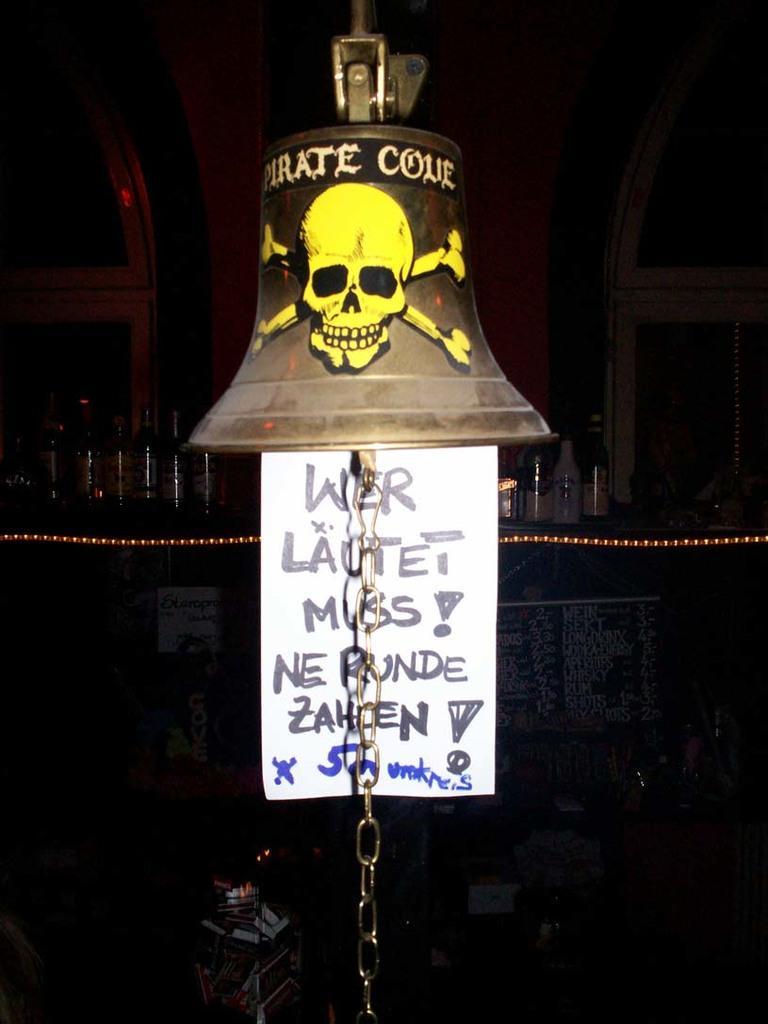Please provide a concise description of this image. In this image, we can see a bell and there is a skull picture on the bell. We can see a poster hanging and there is a dark background. 